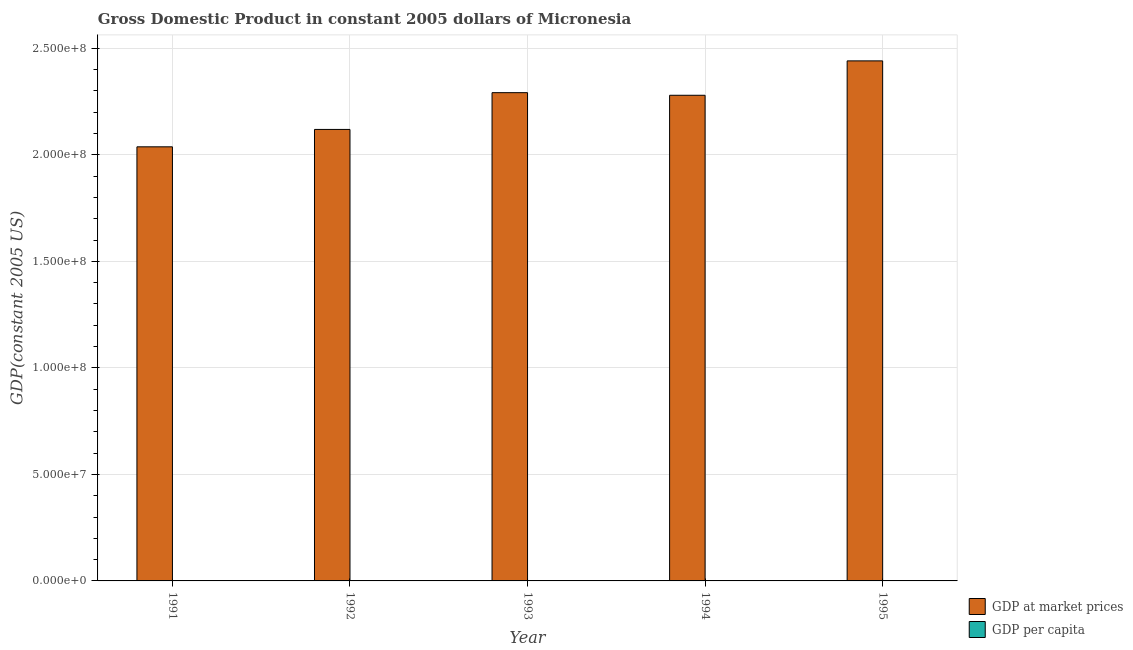How many different coloured bars are there?
Offer a very short reply. 2. Are the number of bars per tick equal to the number of legend labels?
Keep it short and to the point. Yes. How many bars are there on the 2nd tick from the left?
Your answer should be very brief. 2. How many bars are there on the 2nd tick from the right?
Your answer should be very brief. 2. What is the gdp at market prices in 1994?
Provide a succinct answer. 2.28e+08. Across all years, what is the maximum gdp at market prices?
Offer a very short reply. 2.44e+08. Across all years, what is the minimum gdp per capita?
Keep it short and to the point. 2062.39. In which year was the gdp at market prices maximum?
Give a very brief answer. 1995. What is the total gdp at market prices in the graph?
Your answer should be very brief. 1.12e+09. What is the difference between the gdp per capita in 1994 and that in 1995?
Provide a succinct answer. -120.19. What is the difference between the gdp at market prices in 1994 and the gdp per capita in 1995?
Keep it short and to the point. -1.61e+07. What is the average gdp per capita per year?
Offer a terse response. 2155.24. What is the ratio of the gdp per capita in 1991 to that in 1995?
Make the answer very short. 0.91. Is the gdp per capita in 1991 less than that in 1995?
Provide a succinct answer. Yes. What is the difference between the highest and the second highest gdp at market prices?
Keep it short and to the point. 1.49e+07. What is the difference between the highest and the lowest gdp per capita?
Ensure brevity in your answer.  207.19. What does the 1st bar from the left in 1994 represents?
Your answer should be very brief. GDP at market prices. What does the 2nd bar from the right in 1993 represents?
Your answer should be compact. GDP at market prices. Are all the bars in the graph horizontal?
Offer a terse response. No. How many years are there in the graph?
Offer a very short reply. 5. What is the difference between two consecutive major ticks on the Y-axis?
Give a very brief answer. 5.00e+07. Are the values on the major ticks of Y-axis written in scientific E-notation?
Your answer should be very brief. Yes. How many legend labels are there?
Provide a short and direct response. 2. How are the legend labels stacked?
Provide a succinct answer. Vertical. What is the title of the graph?
Keep it short and to the point. Gross Domestic Product in constant 2005 dollars of Micronesia. What is the label or title of the Y-axis?
Your answer should be compact. GDP(constant 2005 US). What is the GDP(constant 2005 US) in GDP at market prices in 1991?
Give a very brief answer. 2.04e+08. What is the GDP(constant 2005 US) in GDP per capita in 1991?
Offer a terse response. 2062.39. What is the GDP(constant 2005 US) in GDP at market prices in 1992?
Your answer should be compact. 2.12e+08. What is the GDP(constant 2005 US) of GDP per capita in 1992?
Keep it short and to the point. 2089.81. What is the GDP(constant 2005 US) of GDP at market prices in 1993?
Make the answer very short. 2.29e+08. What is the GDP(constant 2005 US) of GDP per capita in 1993?
Your response must be concise. 2205.03. What is the GDP(constant 2005 US) of GDP at market prices in 1994?
Offer a very short reply. 2.28e+08. What is the GDP(constant 2005 US) in GDP per capita in 1994?
Make the answer very short. 2149.4. What is the GDP(constant 2005 US) of GDP at market prices in 1995?
Offer a terse response. 2.44e+08. What is the GDP(constant 2005 US) in GDP per capita in 1995?
Offer a terse response. 2269.59. Across all years, what is the maximum GDP(constant 2005 US) in GDP at market prices?
Ensure brevity in your answer.  2.44e+08. Across all years, what is the maximum GDP(constant 2005 US) in GDP per capita?
Make the answer very short. 2269.59. Across all years, what is the minimum GDP(constant 2005 US) of GDP at market prices?
Your answer should be very brief. 2.04e+08. Across all years, what is the minimum GDP(constant 2005 US) of GDP per capita?
Keep it short and to the point. 2062.39. What is the total GDP(constant 2005 US) of GDP at market prices in the graph?
Give a very brief answer. 1.12e+09. What is the total GDP(constant 2005 US) in GDP per capita in the graph?
Give a very brief answer. 1.08e+04. What is the difference between the GDP(constant 2005 US) in GDP at market prices in 1991 and that in 1992?
Provide a short and direct response. -8.17e+06. What is the difference between the GDP(constant 2005 US) in GDP per capita in 1991 and that in 1992?
Ensure brevity in your answer.  -27.41. What is the difference between the GDP(constant 2005 US) of GDP at market prices in 1991 and that in 1993?
Keep it short and to the point. -2.54e+07. What is the difference between the GDP(constant 2005 US) in GDP per capita in 1991 and that in 1993?
Offer a terse response. -142.63. What is the difference between the GDP(constant 2005 US) in GDP at market prices in 1991 and that in 1994?
Ensure brevity in your answer.  -2.42e+07. What is the difference between the GDP(constant 2005 US) of GDP per capita in 1991 and that in 1994?
Offer a terse response. -87.01. What is the difference between the GDP(constant 2005 US) of GDP at market prices in 1991 and that in 1995?
Provide a succinct answer. -4.03e+07. What is the difference between the GDP(constant 2005 US) in GDP per capita in 1991 and that in 1995?
Offer a terse response. -207.19. What is the difference between the GDP(constant 2005 US) in GDP at market prices in 1992 and that in 1993?
Keep it short and to the point. -1.73e+07. What is the difference between the GDP(constant 2005 US) of GDP per capita in 1992 and that in 1993?
Give a very brief answer. -115.22. What is the difference between the GDP(constant 2005 US) of GDP at market prices in 1992 and that in 1994?
Give a very brief answer. -1.60e+07. What is the difference between the GDP(constant 2005 US) of GDP per capita in 1992 and that in 1994?
Provide a short and direct response. -59.59. What is the difference between the GDP(constant 2005 US) in GDP at market prices in 1992 and that in 1995?
Offer a terse response. -3.22e+07. What is the difference between the GDP(constant 2005 US) in GDP per capita in 1992 and that in 1995?
Provide a short and direct response. -179.78. What is the difference between the GDP(constant 2005 US) in GDP at market prices in 1993 and that in 1994?
Provide a short and direct response. 1.23e+06. What is the difference between the GDP(constant 2005 US) of GDP per capita in 1993 and that in 1994?
Provide a short and direct response. 55.63. What is the difference between the GDP(constant 2005 US) of GDP at market prices in 1993 and that in 1995?
Make the answer very short. -1.49e+07. What is the difference between the GDP(constant 2005 US) of GDP per capita in 1993 and that in 1995?
Provide a succinct answer. -64.56. What is the difference between the GDP(constant 2005 US) of GDP at market prices in 1994 and that in 1995?
Your response must be concise. -1.61e+07. What is the difference between the GDP(constant 2005 US) of GDP per capita in 1994 and that in 1995?
Provide a short and direct response. -120.19. What is the difference between the GDP(constant 2005 US) of GDP at market prices in 1991 and the GDP(constant 2005 US) of GDP per capita in 1992?
Your response must be concise. 2.04e+08. What is the difference between the GDP(constant 2005 US) of GDP at market prices in 1991 and the GDP(constant 2005 US) of GDP per capita in 1993?
Your response must be concise. 2.04e+08. What is the difference between the GDP(constant 2005 US) of GDP at market prices in 1991 and the GDP(constant 2005 US) of GDP per capita in 1994?
Offer a terse response. 2.04e+08. What is the difference between the GDP(constant 2005 US) of GDP at market prices in 1991 and the GDP(constant 2005 US) of GDP per capita in 1995?
Provide a succinct answer. 2.04e+08. What is the difference between the GDP(constant 2005 US) of GDP at market prices in 1992 and the GDP(constant 2005 US) of GDP per capita in 1993?
Your answer should be very brief. 2.12e+08. What is the difference between the GDP(constant 2005 US) of GDP at market prices in 1992 and the GDP(constant 2005 US) of GDP per capita in 1994?
Keep it short and to the point. 2.12e+08. What is the difference between the GDP(constant 2005 US) in GDP at market prices in 1992 and the GDP(constant 2005 US) in GDP per capita in 1995?
Your answer should be very brief. 2.12e+08. What is the difference between the GDP(constant 2005 US) of GDP at market prices in 1993 and the GDP(constant 2005 US) of GDP per capita in 1994?
Make the answer very short. 2.29e+08. What is the difference between the GDP(constant 2005 US) in GDP at market prices in 1993 and the GDP(constant 2005 US) in GDP per capita in 1995?
Your response must be concise. 2.29e+08. What is the difference between the GDP(constant 2005 US) of GDP at market prices in 1994 and the GDP(constant 2005 US) of GDP per capita in 1995?
Ensure brevity in your answer.  2.28e+08. What is the average GDP(constant 2005 US) in GDP at market prices per year?
Offer a very short reply. 2.23e+08. What is the average GDP(constant 2005 US) in GDP per capita per year?
Your answer should be compact. 2155.24. In the year 1991, what is the difference between the GDP(constant 2005 US) of GDP at market prices and GDP(constant 2005 US) of GDP per capita?
Offer a terse response. 2.04e+08. In the year 1992, what is the difference between the GDP(constant 2005 US) of GDP at market prices and GDP(constant 2005 US) of GDP per capita?
Keep it short and to the point. 2.12e+08. In the year 1993, what is the difference between the GDP(constant 2005 US) in GDP at market prices and GDP(constant 2005 US) in GDP per capita?
Offer a terse response. 2.29e+08. In the year 1994, what is the difference between the GDP(constant 2005 US) in GDP at market prices and GDP(constant 2005 US) in GDP per capita?
Offer a terse response. 2.28e+08. In the year 1995, what is the difference between the GDP(constant 2005 US) of GDP at market prices and GDP(constant 2005 US) of GDP per capita?
Your answer should be compact. 2.44e+08. What is the ratio of the GDP(constant 2005 US) in GDP at market prices in 1991 to that in 1992?
Your answer should be very brief. 0.96. What is the ratio of the GDP(constant 2005 US) in GDP per capita in 1991 to that in 1992?
Your response must be concise. 0.99. What is the ratio of the GDP(constant 2005 US) in GDP at market prices in 1991 to that in 1993?
Offer a terse response. 0.89. What is the ratio of the GDP(constant 2005 US) in GDP per capita in 1991 to that in 1993?
Offer a terse response. 0.94. What is the ratio of the GDP(constant 2005 US) of GDP at market prices in 1991 to that in 1994?
Offer a terse response. 0.89. What is the ratio of the GDP(constant 2005 US) of GDP per capita in 1991 to that in 1994?
Keep it short and to the point. 0.96. What is the ratio of the GDP(constant 2005 US) in GDP at market prices in 1991 to that in 1995?
Offer a very short reply. 0.83. What is the ratio of the GDP(constant 2005 US) in GDP per capita in 1991 to that in 1995?
Offer a very short reply. 0.91. What is the ratio of the GDP(constant 2005 US) in GDP at market prices in 1992 to that in 1993?
Offer a very short reply. 0.92. What is the ratio of the GDP(constant 2005 US) in GDP per capita in 1992 to that in 1993?
Ensure brevity in your answer.  0.95. What is the ratio of the GDP(constant 2005 US) in GDP at market prices in 1992 to that in 1994?
Offer a very short reply. 0.93. What is the ratio of the GDP(constant 2005 US) in GDP per capita in 1992 to that in 1994?
Your response must be concise. 0.97. What is the ratio of the GDP(constant 2005 US) of GDP at market prices in 1992 to that in 1995?
Your response must be concise. 0.87. What is the ratio of the GDP(constant 2005 US) of GDP per capita in 1992 to that in 1995?
Provide a short and direct response. 0.92. What is the ratio of the GDP(constant 2005 US) in GDP at market prices in 1993 to that in 1994?
Make the answer very short. 1.01. What is the ratio of the GDP(constant 2005 US) of GDP per capita in 1993 to that in 1994?
Provide a short and direct response. 1.03. What is the ratio of the GDP(constant 2005 US) in GDP at market prices in 1993 to that in 1995?
Your answer should be very brief. 0.94. What is the ratio of the GDP(constant 2005 US) of GDP per capita in 1993 to that in 1995?
Your response must be concise. 0.97. What is the ratio of the GDP(constant 2005 US) in GDP at market prices in 1994 to that in 1995?
Keep it short and to the point. 0.93. What is the ratio of the GDP(constant 2005 US) of GDP per capita in 1994 to that in 1995?
Offer a very short reply. 0.95. What is the difference between the highest and the second highest GDP(constant 2005 US) in GDP at market prices?
Offer a terse response. 1.49e+07. What is the difference between the highest and the second highest GDP(constant 2005 US) in GDP per capita?
Offer a very short reply. 64.56. What is the difference between the highest and the lowest GDP(constant 2005 US) in GDP at market prices?
Keep it short and to the point. 4.03e+07. What is the difference between the highest and the lowest GDP(constant 2005 US) in GDP per capita?
Offer a terse response. 207.19. 